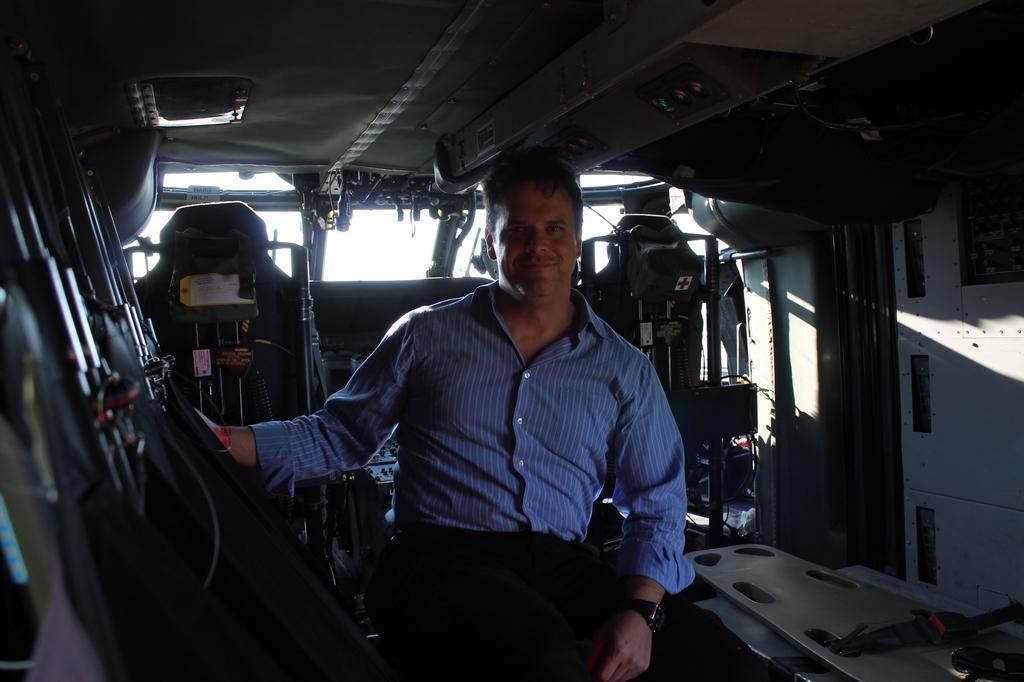Can you describe this image briefly? In this image I can see the interior of the vehicle in which I can see a person sitting, few seats, the ceiling, a light to the ceiling and few other objects. 